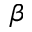Convert formula to latex. <formula><loc_0><loc_0><loc_500><loc_500>\beta</formula> 